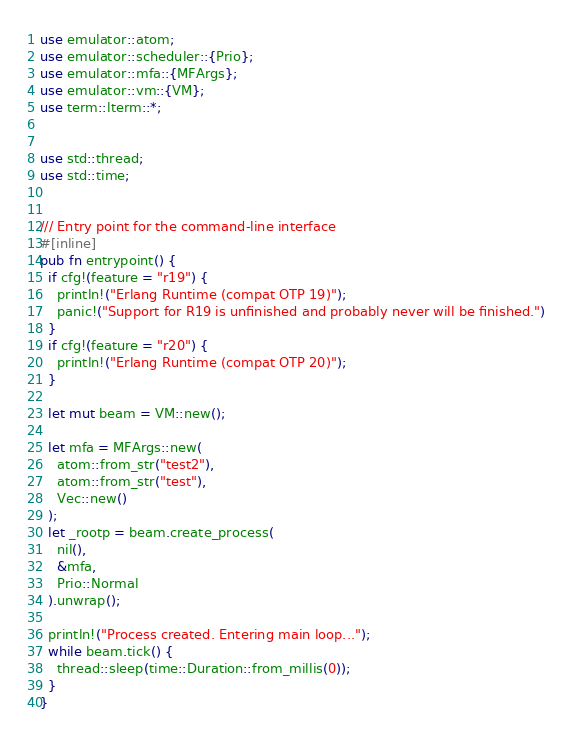<code> <loc_0><loc_0><loc_500><loc_500><_Rust_>use emulator::atom;
use emulator::scheduler::{Prio};
use emulator::mfa::{MFArgs};
use emulator::vm::{VM};
use term::lterm::*;


use std::thread;
use std::time;


/// Entry point for the command-line interface
#[inline]
pub fn entrypoint() {
  if cfg!(feature = "r19") {
    println!("Erlang Runtime (compat OTP 19)");
    panic!("Support for R19 is unfinished and probably never will be finished.")
  }
  if cfg!(feature = "r20") {
    println!("Erlang Runtime (compat OTP 20)");
  }

  let mut beam = VM::new();

  let mfa = MFArgs::new(
    atom::from_str("test2"),
    atom::from_str("test"),
    Vec::new()
  );
  let _rootp = beam.create_process(
    nil(),
    &mfa,
    Prio::Normal
  ).unwrap();

  println!("Process created. Entering main loop...");
  while beam.tick() {
    thread::sleep(time::Duration::from_millis(0));
  }
}
</code> 